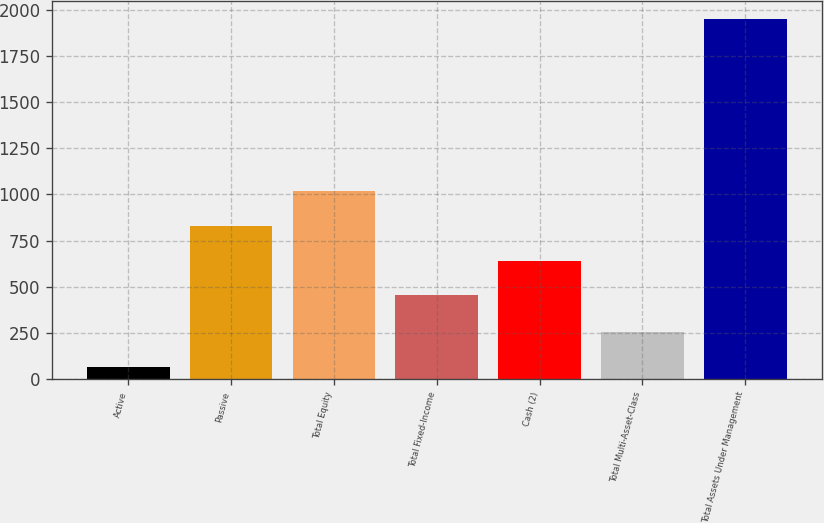Convert chart to OTSL. <chart><loc_0><loc_0><loc_500><loc_500><bar_chart><fcel>Active<fcel>Passive<fcel>Total Equity<fcel>Total Fixed-Income<fcel>Cash (2)<fcel>Total Multi-Asset-Class<fcel>Total Assets Under Management<nl><fcel>68<fcel>830.6<fcel>1018.9<fcel>454<fcel>642.3<fcel>256.3<fcel>1951<nl></chart> 